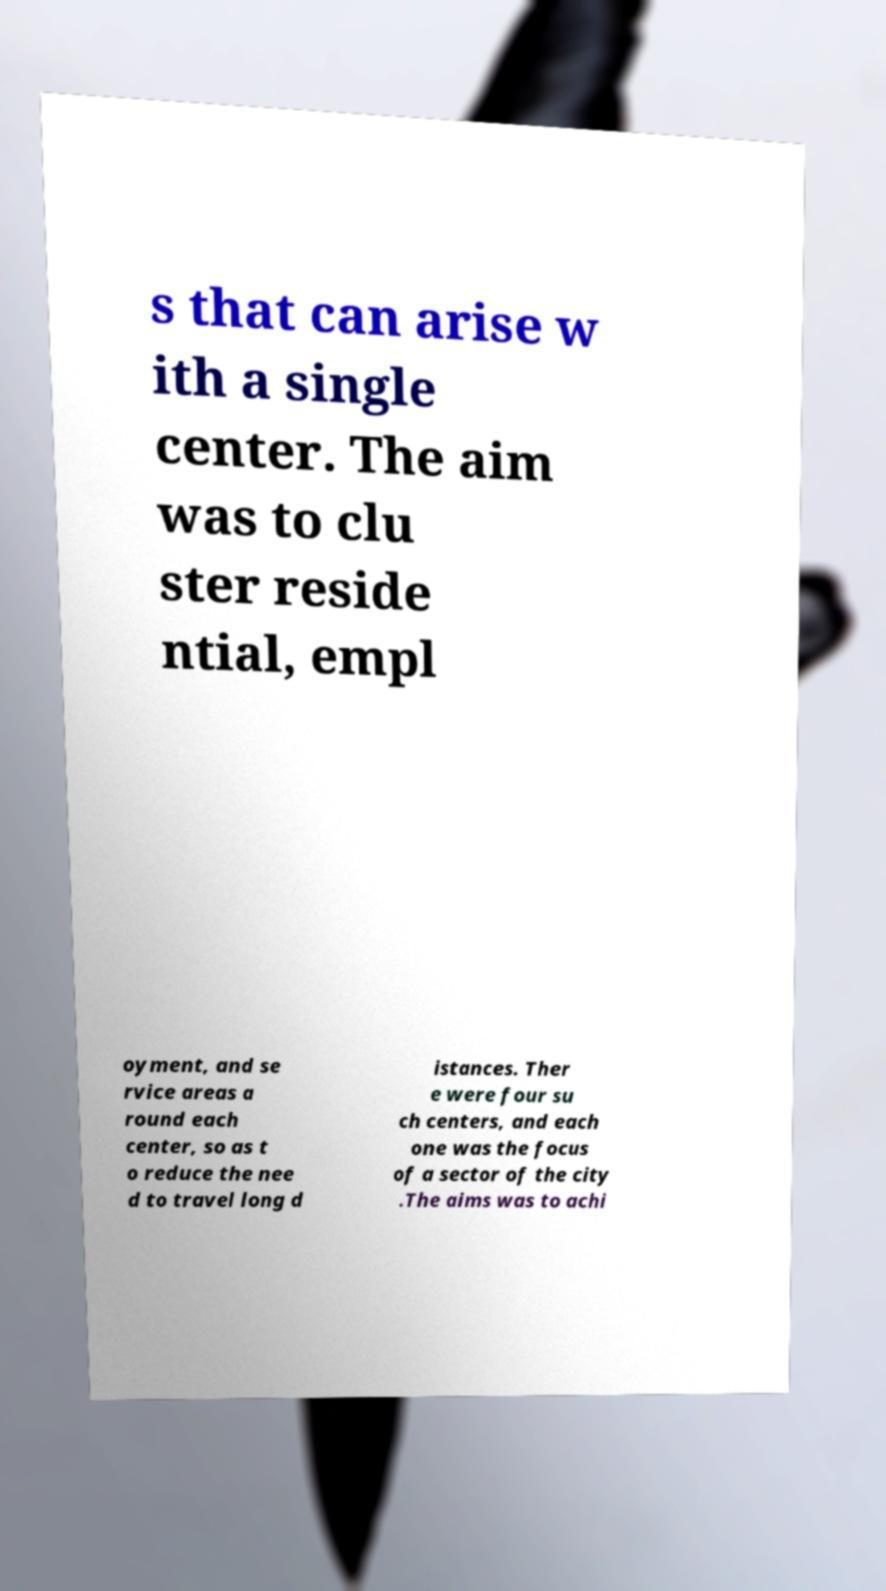For documentation purposes, I need the text within this image transcribed. Could you provide that? s that can arise w ith a single center. The aim was to clu ster reside ntial, empl oyment, and se rvice areas a round each center, so as t o reduce the nee d to travel long d istances. Ther e were four su ch centers, and each one was the focus of a sector of the city .The aims was to achi 